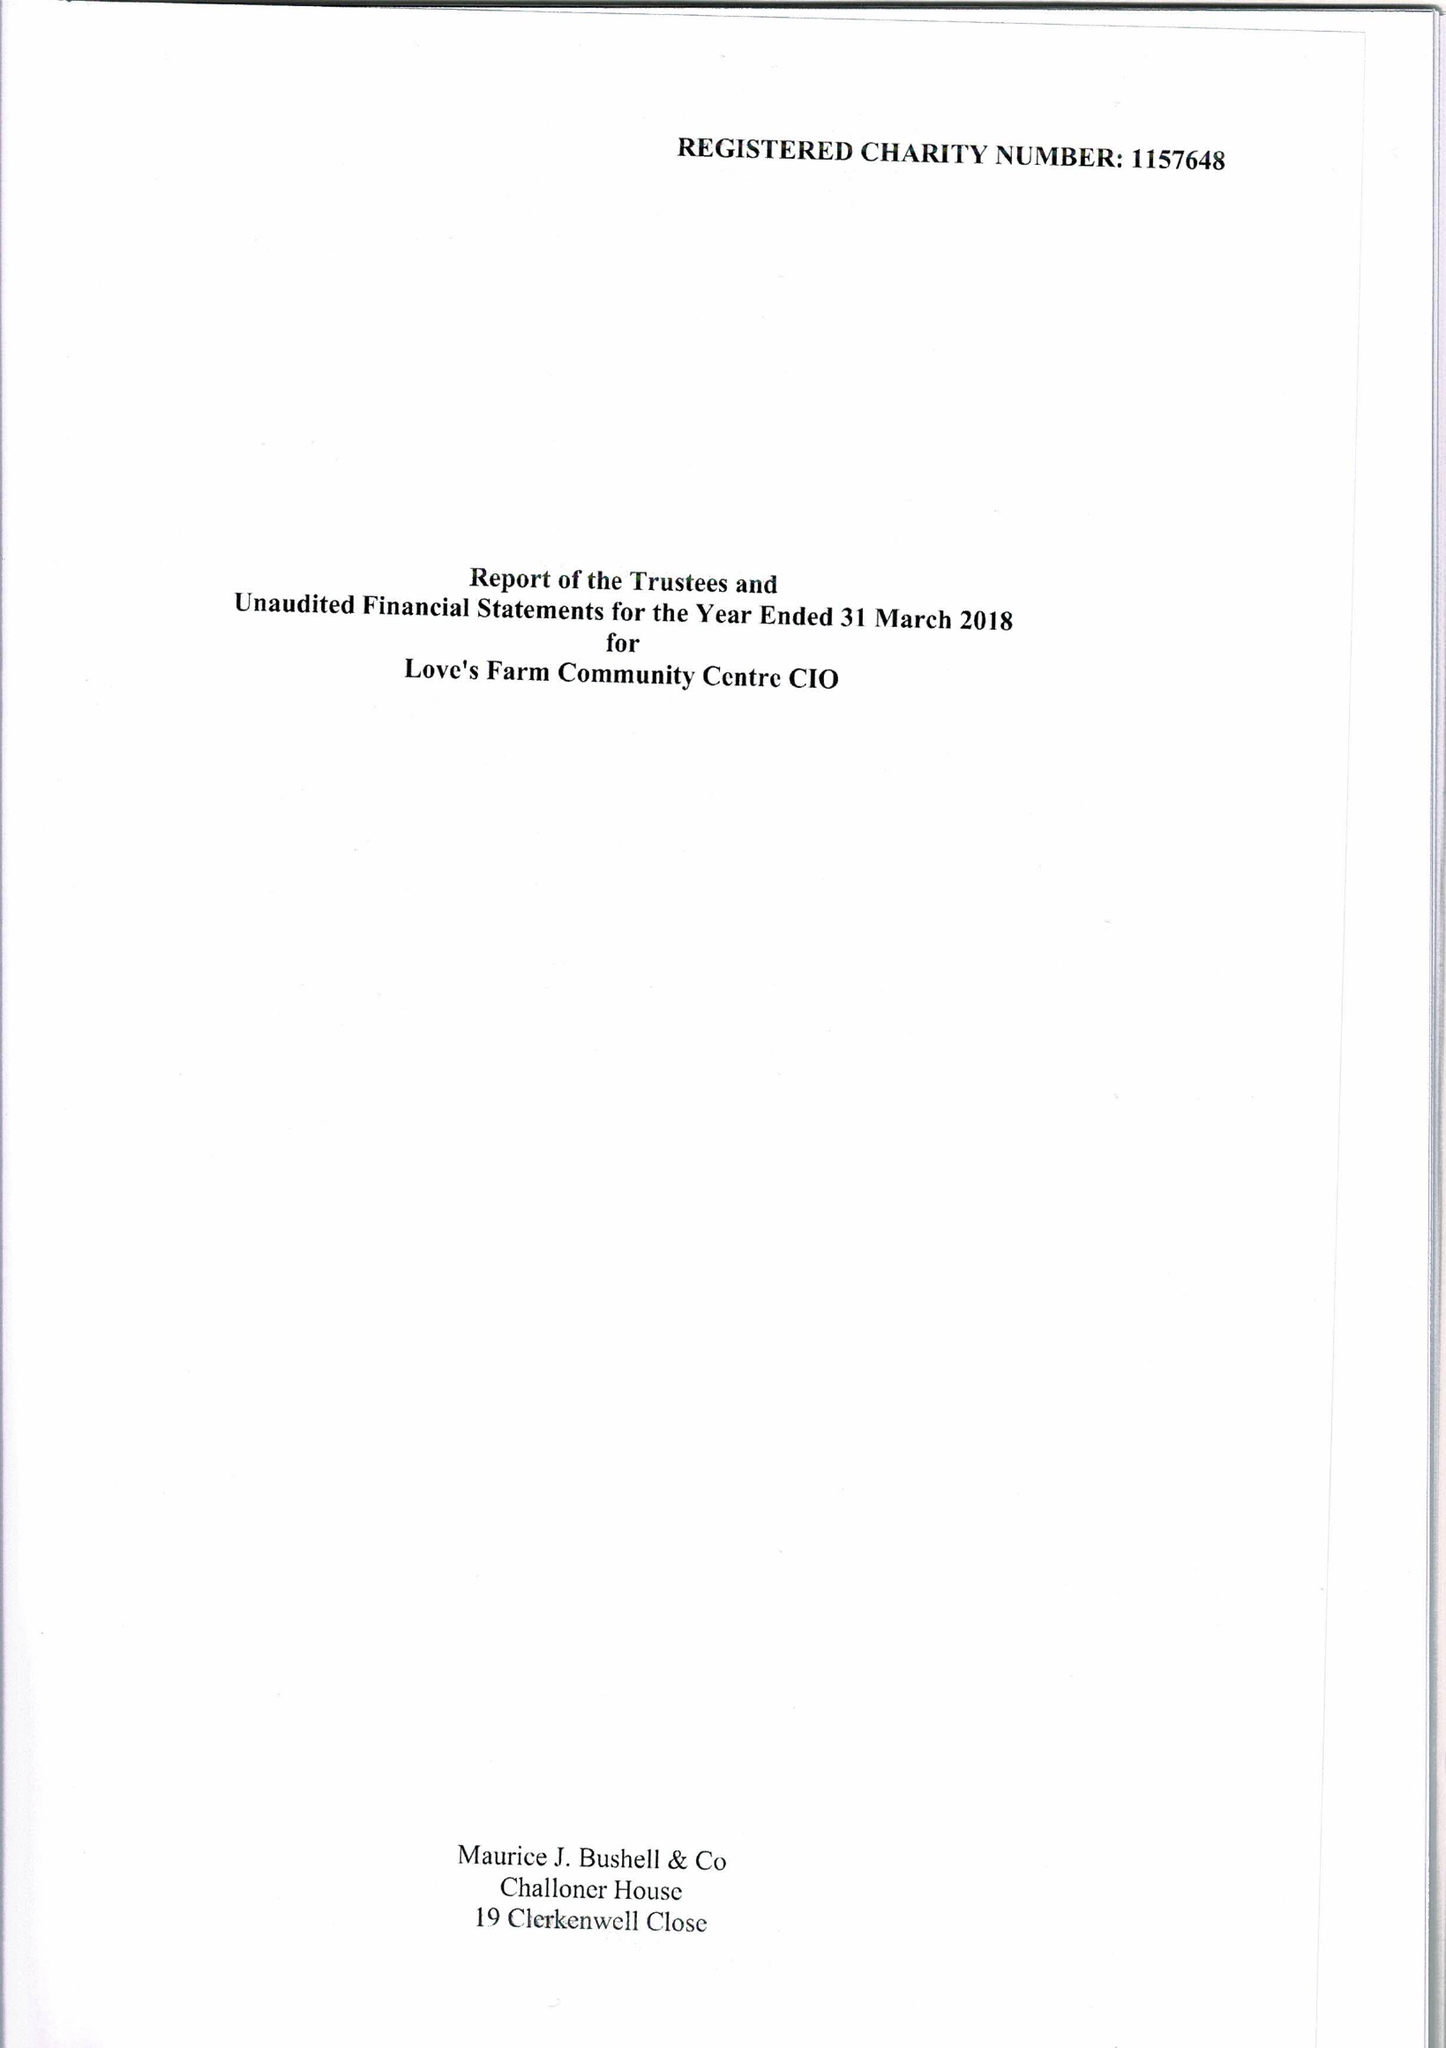What is the value for the income_annually_in_british_pounds?
Answer the question using a single word or phrase. 109882.00 